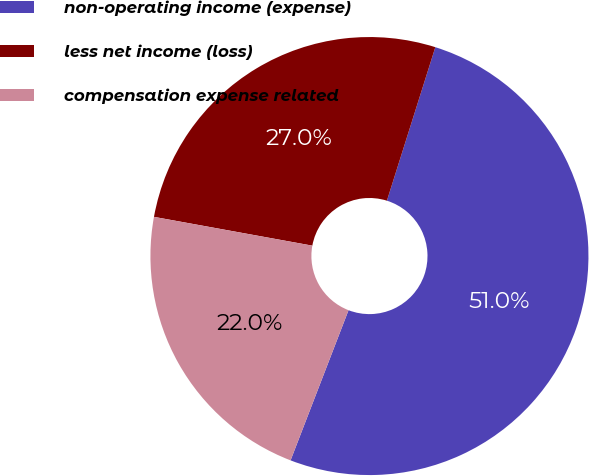Convert chart to OTSL. <chart><loc_0><loc_0><loc_500><loc_500><pie_chart><fcel>non-operating income (expense)<fcel>less net income (loss)<fcel>compensation expense related<nl><fcel>51.0%<fcel>27.0%<fcel>22.0%<nl></chart> 